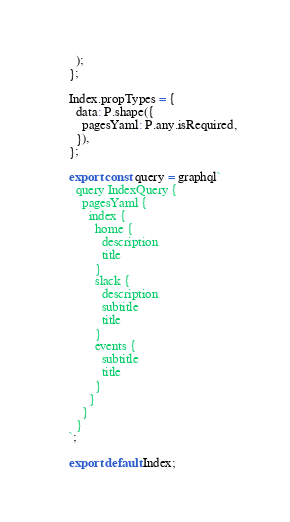Convert code to text. <code><loc_0><loc_0><loc_500><loc_500><_JavaScript_>  );
};

Index.propTypes = {
  data: P.shape({
    pagesYaml: P.any.isRequired,
  }),
};

export const query = graphql`
  query IndexQuery {
    pagesYaml {
      index {
        home {
          description
          title
        }
        slack {
          description
          subtitle
          title
        }
        events {
          subtitle
          title
        }
      }
    }
  }
`;

export default Index;
</code> 